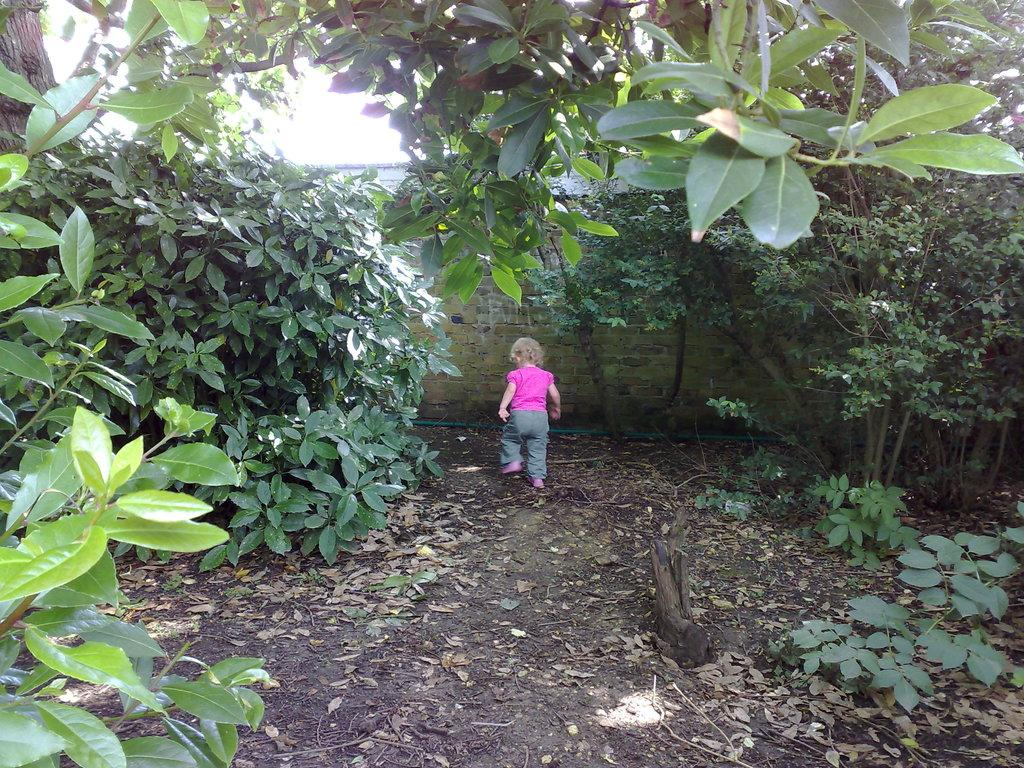What type of living organisms can be seen in the image? Plants and a tree are visible in the image. What is the background of the image? There is a wall in the image, and the sky is visible. Can you describe the child in the image? The child is wearing a pink dress. How many dolls are sitting on the branches of the tree in the image? There are no dolls present in the image; it features plants, a tree, a wall, the sky, and a child wearing a pink dress. What type of straw is used to decorate the plants in the image? There is no straw present in the image; it only features plants, a tree, a wall, the sky, and a child wearing a pink dress. 